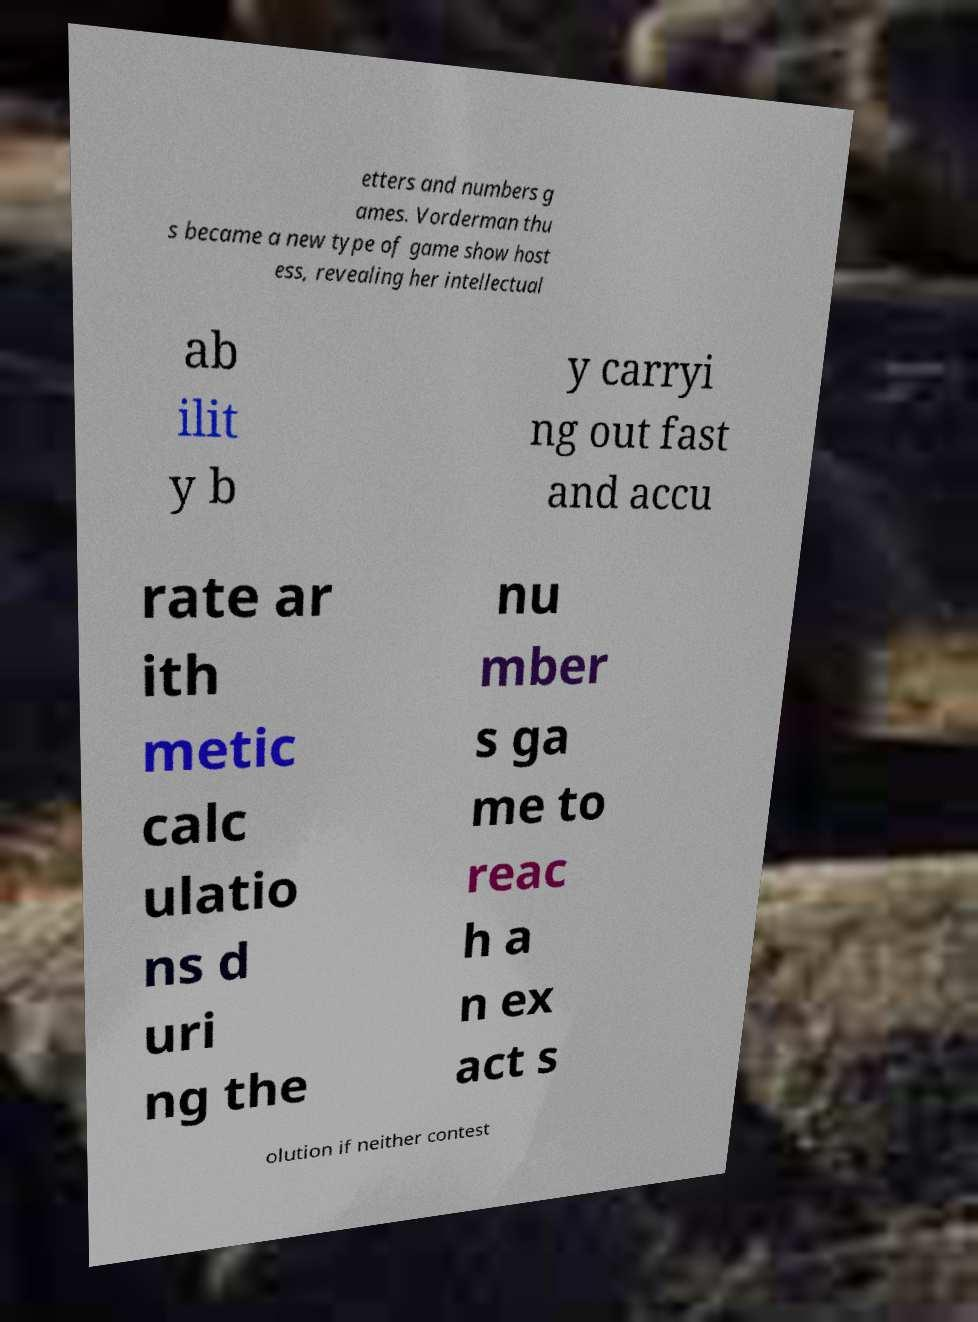Can you read and provide the text displayed in the image?This photo seems to have some interesting text. Can you extract and type it out for me? etters and numbers g ames. Vorderman thu s became a new type of game show host ess, revealing her intellectual ab ilit y b y carryi ng out fast and accu rate ar ith metic calc ulatio ns d uri ng the nu mber s ga me to reac h a n ex act s olution if neither contest 